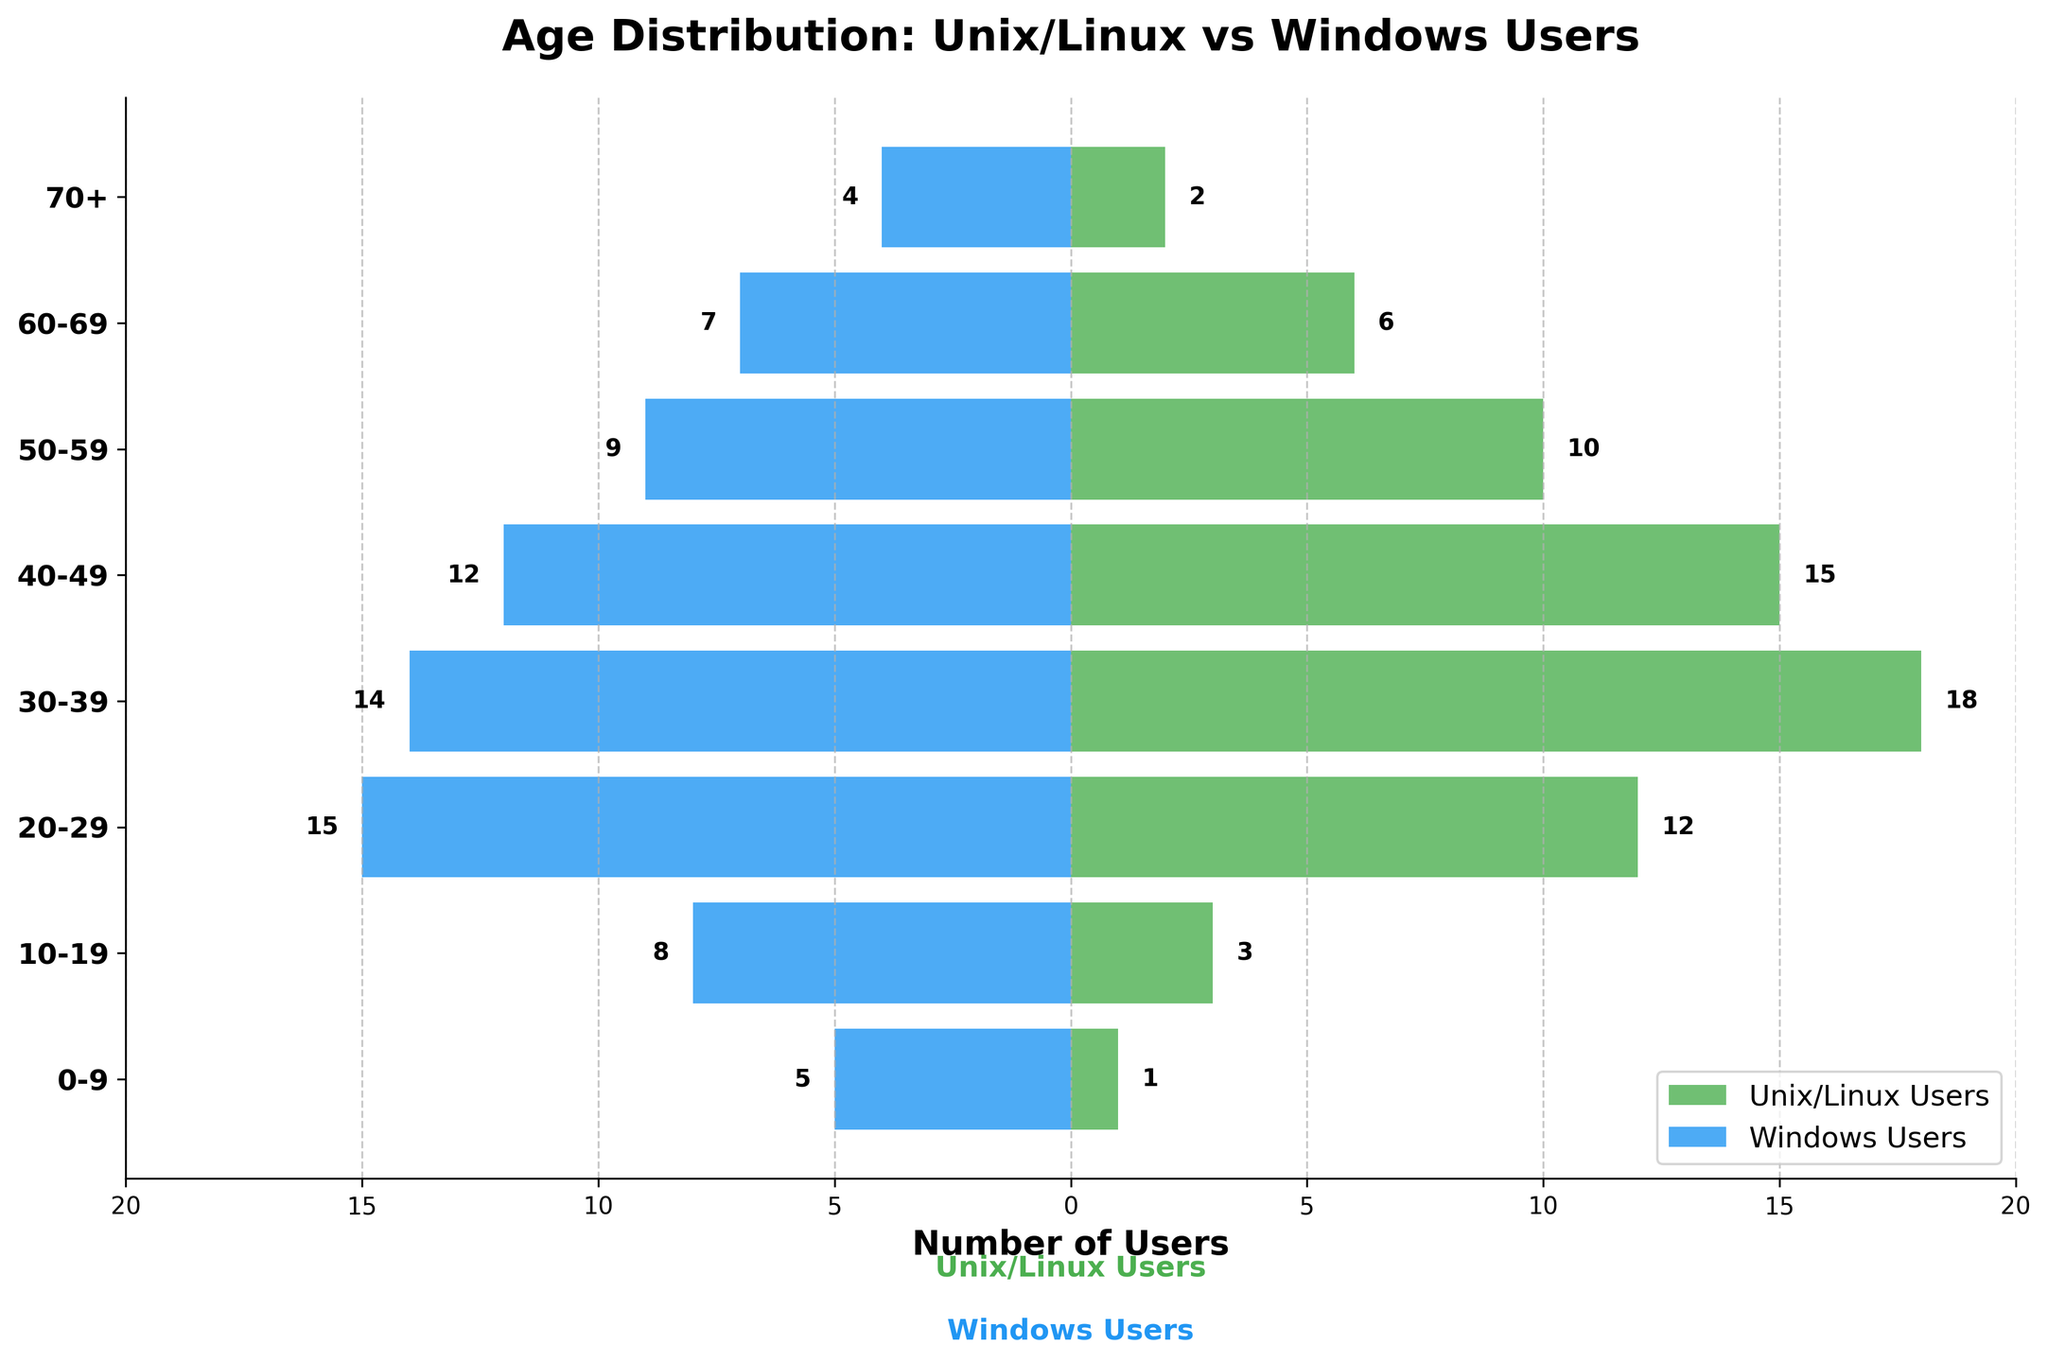What is the title of the plot? The title is given at the top of the plot and it provides a description of what the plot represents.
Answer: Age Distribution: Unix/Linux vs Windows Users What age group has the highest number of Unix/Linux users? By observing the green bars corresponding to each age group, the longest green bar represents the age group with the highest number of Unix/Linux users.
Answer: 30-39 Which age group has more Windows users than Unix/Linux users? By comparing the lengths of the blue and green bars for each age group, the age groups where the blue bar is longer than the green bar can be found.
Answer: 0-9, 10-19, 70+ How many Unix/Linux users are in the age group 50-59? Find the length of the green bar corresponding to the age group 50-59 and read the value.
Answer: 10 How does the number of Unix/Linux users aged 40-49 compare to that of Windows users in the same age group? Compare the length of the green bar (Unix/Linux) to the length of the blue bar (Windows) in the age group 40-49.
Answer: More Unix/Linux users In the age group 10-19, what is the difference in the number of users between Unix/Linux and Windows? Find the number of Unix/Linux users and Windows users in the age group 10-19, then subtract the smaller number from the larger number (8 - 3).
Answer: 5 What is the sum of Unix/Linux and Windows users in the age group 60-69? Add the number of Unix/Linux users and Windows users in the age group 60-69 (6 + 7).
Answer: 13 Which age group has the smallest number of Unix/Linux users? The shortest green bar represents the age group with the smallest number of Unix/Linux users.
Answer: 0-9 Which age group has an equal number of Unix/Linux and Windows users? Compare the lengths of the green and blue bars for each age group to find the age group where both bars have the same length.
Answer: None What is the combined total of Unix/Linux and Windows users across all age groups? Add the number of Unix/Linux users and Windows users for each age group and then sum all these totals. (1+3+12+18+15+10+6+2) + (5+8+15+14+12+9+7+4) = 67 + 74
Answer: 141 